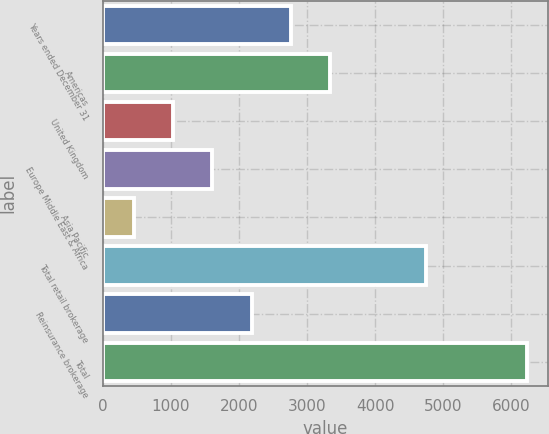<chart> <loc_0><loc_0><loc_500><loc_500><bar_chart><fcel>Years ended December 31<fcel>Americas<fcel>United Kingdom<fcel>Europe Middle East & Africa<fcel>Asia Pacific<fcel>Total retail brokerage<fcel>Reinsurance brokerage<fcel>Total<nl><fcel>2766.4<fcel>3344<fcel>1033.6<fcel>1611.2<fcel>456<fcel>4747<fcel>2188.8<fcel>6232<nl></chart> 